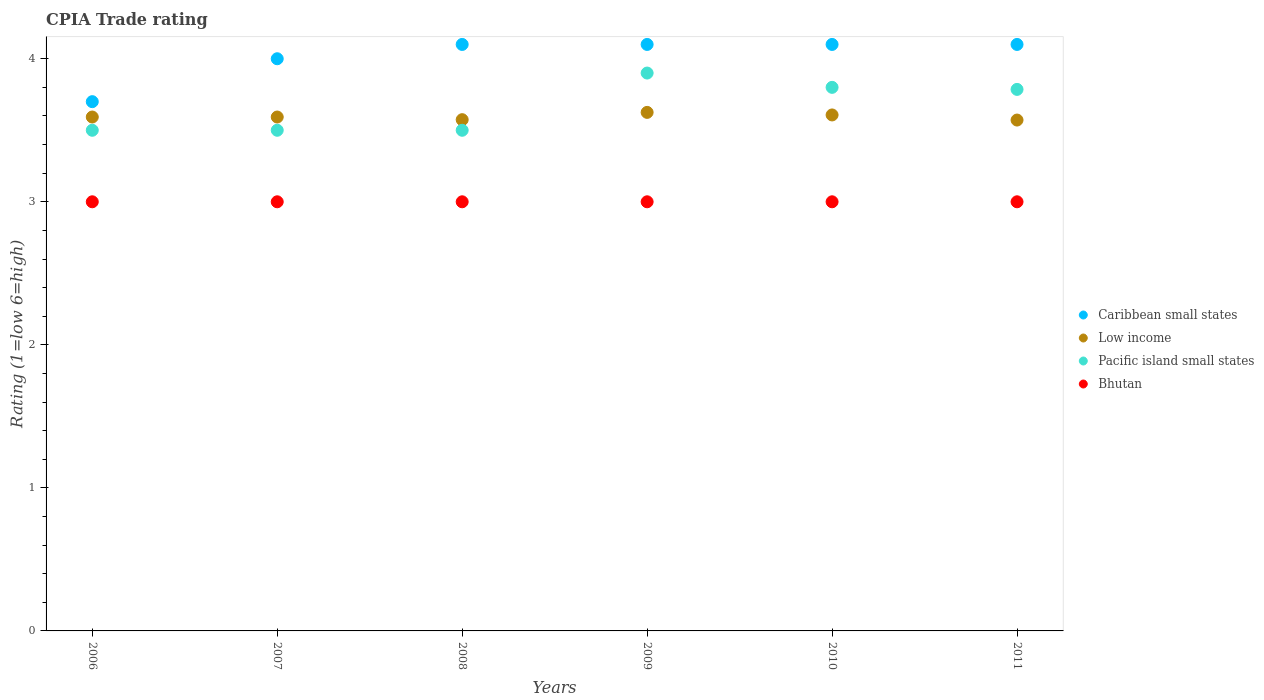How many different coloured dotlines are there?
Provide a short and direct response. 4. Is the number of dotlines equal to the number of legend labels?
Your response must be concise. Yes. What is the CPIA rating in Low income in 2009?
Give a very brief answer. 3.62. Across all years, what is the maximum CPIA rating in Bhutan?
Offer a very short reply. 3. In which year was the CPIA rating in Caribbean small states maximum?
Make the answer very short. 2008. In which year was the CPIA rating in Pacific island small states minimum?
Provide a short and direct response. 2006. What is the total CPIA rating in Low income in the graph?
Ensure brevity in your answer.  21.56. What is the difference between the CPIA rating in Bhutan in 2011 and the CPIA rating in Caribbean small states in 2010?
Provide a succinct answer. -1.1. What is the average CPIA rating in Caribbean small states per year?
Provide a succinct answer. 4.02. In the year 2010, what is the difference between the CPIA rating in Low income and CPIA rating in Bhutan?
Offer a terse response. 0.61. What is the ratio of the CPIA rating in Caribbean small states in 2007 to that in 2011?
Your answer should be compact. 0.98. What is the difference between the highest and the second highest CPIA rating in Low income?
Your answer should be very brief. 0.02. What is the difference between the highest and the lowest CPIA rating in Pacific island small states?
Your response must be concise. 0.4. In how many years, is the CPIA rating in Bhutan greater than the average CPIA rating in Bhutan taken over all years?
Your response must be concise. 0. Is the sum of the CPIA rating in Bhutan in 2007 and 2009 greater than the maximum CPIA rating in Caribbean small states across all years?
Keep it short and to the point. Yes. Is it the case that in every year, the sum of the CPIA rating in Pacific island small states and CPIA rating in Bhutan  is greater than the sum of CPIA rating in Low income and CPIA rating in Caribbean small states?
Offer a very short reply. Yes. Is the CPIA rating in Low income strictly less than the CPIA rating in Bhutan over the years?
Your response must be concise. No. How many dotlines are there?
Your response must be concise. 4. How many years are there in the graph?
Your answer should be very brief. 6. What is the difference between two consecutive major ticks on the Y-axis?
Offer a terse response. 1. Does the graph contain grids?
Provide a short and direct response. No. How many legend labels are there?
Your answer should be compact. 4. What is the title of the graph?
Your answer should be very brief. CPIA Trade rating. Does "Korea (Democratic)" appear as one of the legend labels in the graph?
Offer a very short reply. No. What is the label or title of the X-axis?
Your answer should be compact. Years. What is the label or title of the Y-axis?
Provide a succinct answer. Rating (1=low 6=high). What is the Rating (1=low 6=high) of Low income in 2006?
Keep it short and to the point. 3.59. What is the Rating (1=low 6=high) of Low income in 2007?
Offer a very short reply. 3.59. What is the Rating (1=low 6=high) in Pacific island small states in 2007?
Your response must be concise. 3.5. What is the Rating (1=low 6=high) of Low income in 2008?
Provide a short and direct response. 3.57. What is the Rating (1=low 6=high) in Caribbean small states in 2009?
Provide a succinct answer. 4.1. What is the Rating (1=low 6=high) of Low income in 2009?
Your answer should be compact. 3.62. What is the Rating (1=low 6=high) in Bhutan in 2009?
Keep it short and to the point. 3. What is the Rating (1=low 6=high) in Caribbean small states in 2010?
Keep it short and to the point. 4.1. What is the Rating (1=low 6=high) in Low income in 2010?
Offer a terse response. 3.61. What is the Rating (1=low 6=high) in Pacific island small states in 2010?
Give a very brief answer. 3.8. What is the Rating (1=low 6=high) in Bhutan in 2010?
Give a very brief answer. 3. What is the Rating (1=low 6=high) of Low income in 2011?
Ensure brevity in your answer.  3.57. What is the Rating (1=low 6=high) of Pacific island small states in 2011?
Your answer should be compact. 3.79. What is the Rating (1=low 6=high) of Bhutan in 2011?
Ensure brevity in your answer.  3. Across all years, what is the maximum Rating (1=low 6=high) of Caribbean small states?
Provide a short and direct response. 4.1. Across all years, what is the maximum Rating (1=low 6=high) of Low income?
Give a very brief answer. 3.62. Across all years, what is the maximum Rating (1=low 6=high) of Pacific island small states?
Your answer should be very brief. 3.9. Across all years, what is the minimum Rating (1=low 6=high) of Caribbean small states?
Give a very brief answer. 3.7. Across all years, what is the minimum Rating (1=low 6=high) of Low income?
Make the answer very short. 3.57. What is the total Rating (1=low 6=high) of Caribbean small states in the graph?
Provide a short and direct response. 24.1. What is the total Rating (1=low 6=high) in Low income in the graph?
Give a very brief answer. 21.56. What is the total Rating (1=low 6=high) in Pacific island small states in the graph?
Provide a succinct answer. 21.99. What is the difference between the Rating (1=low 6=high) of Low income in 2006 and that in 2007?
Ensure brevity in your answer.  0. What is the difference between the Rating (1=low 6=high) of Low income in 2006 and that in 2008?
Keep it short and to the point. 0.02. What is the difference between the Rating (1=low 6=high) in Pacific island small states in 2006 and that in 2008?
Provide a succinct answer. 0. What is the difference between the Rating (1=low 6=high) of Bhutan in 2006 and that in 2008?
Offer a very short reply. 0. What is the difference between the Rating (1=low 6=high) of Low income in 2006 and that in 2009?
Ensure brevity in your answer.  -0.03. What is the difference between the Rating (1=low 6=high) in Pacific island small states in 2006 and that in 2009?
Ensure brevity in your answer.  -0.4. What is the difference between the Rating (1=low 6=high) in Caribbean small states in 2006 and that in 2010?
Provide a succinct answer. -0.4. What is the difference between the Rating (1=low 6=high) of Low income in 2006 and that in 2010?
Give a very brief answer. -0.01. What is the difference between the Rating (1=low 6=high) of Pacific island small states in 2006 and that in 2010?
Your answer should be very brief. -0.3. What is the difference between the Rating (1=low 6=high) in Bhutan in 2006 and that in 2010?
Ensure brevity in your answer.  0. What is the difference between the Rating (1=low 6=high) of Low income in 2006 and that in 2011?
Offer a terse response. 0.02. What is the difference between the Rating (1=low 6=high) of Pacific island small states in 2006 and that in 2011?
Provide a succinct answer. -0.29. What is the difference between the Rating (1=low 6=high) in Bhutan in 2006 and that in 2011?
Offer a very short reply. 0. What is the difference between the Rating (1=low 6=high) of Low income in 2007 and that in 2008?
Keep it short and to the point. 0.02. What is the difference between the Rating (1=low 6=high) in Caribbean small states in 2007 and that in 2009?
Your response must be concise. -0.1. What is the difference between the Rating (1=low 6=high) of Low income in 2007 and that in 2009?
Your response must be concise. -0.03. What is the difference between the Rating (1=low 6=high) in Pacific island small states in 2007 and that in 2009?
Your answer should be compact. -0.4. What is the difference between the Rating (1=low 6=high) of Low income in 2007 and that in 2010?
Offer a very short reply. -0.01. What is the difference between the Rating (1=low 6=high) of Bhutan in 2007 and that in 2010?
Provide a short and direct response. 0. What is the difference between the Rating (1=low 6=high) in Low income in 2007 and that in 2011?
Your answer should be compact. 0.02. What is the difference between the Rating (1=low 6=high) in Pacific island small states in 2007 and that in 2011?
Offer a terse response. -0.29. What is the difference between the Rating (1=low 6=high) of Bhutan in 2007 and that in 2011?
Give a very brief answer. 0. What is the difference between the Rating (1=low 6=high) of Low income in 2008 and that in 2009?
Provide a short and direct response. -0.05. What is the difference between the Rating (1=low 6=high) of Pacific island small states in 2008 and that in 2009?
Provide a short and direct response. -0.4. What is the difference between the Rating (1=low 6=high) of Bhutan in 2008 and that in 2009?
Give a very brief answer. 0. What is the difference between the Rating (1=low 6=high) of Caribbean small states in 2008 and that in 2010?
Keep it short and to the point. 0. What is the difference between the Rating (1=low 6=high) in Low income in 2008 and that in 2010?
Give a very brief answer. -0.03. What is the difference between the Rating (1=low 6=high) in Pacific island small states in 2008 and that in 2010?
Your answer should be very brief. -0.3. What is the difference between the Rating (1=low 6=high) of Bhutan in 2008 and that in 2010?
Provide a succinct answer. 0. What is the difference between the Rating (1=low 6=high) of Low income in 2008 and that in 2011?
Your answer should be compact. 0. What is the difference between the Rating (1=low 6=high) of Pacific island small states in 2008 and that in 2011?
Provide a succinct answer. -0.29. What is the difference between the Rating (1=low 6=high) in Bhutan in 2008 and that in 2011?
Ensure brevity in your answer.  0. What is the difference between the Rating (1=low 6=high) in Low income in 2009 and that in 2010?
Ensure brevity in your answer.  0.02. What is the difference between the Rating (1=low 6=high) of Bhutan in 2009 and that in 2010?
Offer a very short reply. 0. What is the difference between the Rating (1=low 6=high) of Low income in 2009 and that in 2011?
Give a very brief answer. 0.05. What is the difference between the Rating (1=low 6=high) in Pacific island small states in 2009 and that in 2011?
Your response must be concise. 0.11. What is the difference between the Rating (1=low 6=high) of Bhutan in 2009 and that in 2011?
Make the answer very short. 0. What is the difference between the Rating (1=low 6=high) in Low income in 2010 and that in 2011?
Provide a short and direct response. 0.04. What is the difference between the Rating (1=low 6=high) in Pacific island small states in 2010 and that in 2011?
Provide a short and direct response. 0.01. What is the difference between the Rating (1=low 6=high) in Caribbean small states in 2006 and the Rating (1=low 6=high) in Low income in 2007?
Make the answer very short. 0.11. What is the difference between the Rating (1=low 6=high) in Caribbean small states in 2006 and the Rating (1=low 6=high) in Pacific island small states in 2007?
Give a very brief answer. 0.2. What is the difference between the Rating (1=low 6=high) in Caribbean small states in 2006 and the Rating (1=low 6=high) in Bhutan in 2007?
Provide a short and direct response. 0.7. What is the difference between the Rating (1=low 6=high) of Low income in 2006 and the Rating (1=low 6=high) of Pacific island small states in 2007?
Ensure brevity in your answer.  0.09. What is the difference between the Rating (1=low 6=high) in Low income in 2006 and the Rating (1=low 6=high) in Bhutan in 2007?
Make the answer very short. 0.59. What is the difference between the Rating (1=low 6=high) in Pacific island small states in 2006 and the Rating (1=low 6=high) in Bhutan in 2007?
Your response must be concise. 0.5. What is the difference between the Rating (1=low 6=high) in Caribbean small states in 2006 and the Rating (1=low 6=high) in Low income in 2008?
Give a very brief answer. 0.13. What is the difference between the Rating (1=low 6=high) of Low income in 2006 and the Rating (1=low 6=high) of Pacific island small states in 2008?
Keep it short and to the point. 0.09. What is the difference between the Rating (1=low 6=high) in Low income in 2006 and the Rating (1=low 6=high) in Bhutan in 2008?
Provide a succinct answer. 0.59. What is the difference between the Rating (1=low 6=high) of Caribbean small states in 2006 and the Rating (1=low 6=high) of Low income in 2009?
Give a very brief answer. 0.07. What is the difference between the Rating (1=low 6=high) of Caribbean small states in 2006 and the Rating (1=low 6=high) of Pacific island small states in 2009?
Offer a very short reply. -0.2. What is the difference between the Rating (1=low 6=high) of Caribbean small states in 2006 and the Rating (1=low 6=high) of Bhutan in 2009?
Keep it short and to the point. 0.7. What is the difference between the Rating (1=low 6=high) of Low income in 2006 and the Rating (1=low 6=high) of Pacific island small states in 2009?
Give a very brief answer. -0.31. What is the difference between the Rating (1=low 6=high) in Low income in 2006 and the Rating (1=low 6=high) in Bhutan in 2009?
Your answer should be compact. 0.59. What is the difference between the Rating (1=low 6=high) in Caribbean small states in 2006 and the Rating (1=low 6=high) in Low income in 2010?
Make the answer very short. 0.09. What is the difference between the Rating (1=low 6=high) of Caribbean small states in 2006 and the Rating (1=low 6=high) of Pacific island small states in 2010?
Your answer should be compact. -0.1. What is the difference between the Rating (1=low 6=high) of Caribbean small states in 2006 and the Rating (1=low 6=high) of Bhutan in 2010?
Your answer should be compact. 0.7. What is the difference between the Rating (1=low 6=high) in Low income in 2006 and the Rating (1=low 6=high) in Pacific island small states in 2010?
Ensure brevity in your answer.  -0.21. What is the difference between the Rating (1=low 6=high) in Low income in 2006 and the Rating (1=low 6=high) in Bhutan in 2010?
Make the answer very short. 0.59. What is the difference between the Rating (1=low 6=high) in Caribbean small states in 2006 and the Rating (1=low 6=high) in Low income in 2011?
Offer a terse response. 0.13. What is the difference between the Rating (1=low 6=high) of Caribbean small states in 2006 and the Rating (1=low 6=high) of Pacific island small states in 2011?
Give a very brief answer. -0.09. What is the difference between the Rating (1=low 6=high) in Low income in 2006 and the Rating (1=low 6=high) in Pacific island small states in 2011?
Your response must be concise. -0.19. What is the difference between the Rating (1=low 6=high) of Low income in 2006 and the Rating (1=low 6=high) of Bhutan in 2011?
Make the answer very short. 0.59. What is the difference between the Rating (1=low 6=high) of Caribbean small states in 2007 and the Rating (1=low 6=high) of Low income in 2008?
Offer a very short reply. 0.43. What is the difference between the Rating (1=low 6=high) in Caribbean small states in 2007 and the Rating (1=low 6=high) in Pacific island small states in 2008?
Make the answer very short. 0.5. What is the difference between the Rating (1=low 6=high) in Caribbean small states in 2007 and the Rating (1=low 6=high) in Bhutan in 2008?
Give a very brief answer. 1. What is the difference between the Rating (1=low 6=high) in Low income in 2007 and the Rating (1=low 6=high) in Pacific island small states in 2008?
Offer a very short reply. 0.09. What is the difference between the Rating (1=low 6=high) of Low income in 2007 and the Rating (1=low 6=high) of Bhutan in 2008?
Provide a short and direct response. 0.59. What is the difference between the Rating (1=low 6=high) in Caribbean small states in 2007 and the Rating (1=low 6=high) in Low income in 2009?
Make the answer very short. 0.38. What is the difference between the Rating (1=low 6=high) of Caribbean small states in 2007 and the Rating (1=low 6=high) of Bhutan in 2009?
Offer a terse response. 1. What is the difference between the Rating (1=low 6=high) in Low income in 2007 and the Rating (1=low 6=high) in Pacific island small states in 2009?
Keep it short and to the point. -0.31. What is the difference between the Rating (1=low 6=high) in Low income in 2007 and the Rating (1=low 6=high) in Bhutan in 2009?
Make the answer very short. 0.59. What is the difference between the Rating (1=low 6=high) of Pacific island small states in 2007 and the Rating (1=low 6=high) of Bhutan in 2009?
Offer a very short reply. 0.5. What is the difference between the Rating (1=low 6=high) in Caribbean small states in 2007 and the Rating (1=low 6=high) in Low income in 2010?
Keep it short and to the point. 0.39. What is the difference between the Rating (1=low 6=high) in Caribbean small states in 2007 and the Rating (1=low 6=high) in Pacific island small states in 2010?
Offer a terse response. 0.2. What is the difference between the Rating (1=low 6=high) in Low income in 2007 and the Rating (1=low 6=high) in Pacific island small states in 2010?
Offer a very short reply. -0.21. What is the difference between the Rating (1=low 6=high) of Low income in 2007 and the Rating (1=low 6=high) of Bhutan in 2010?
Make the answer very short. 0.59. What is the difference between the Rating (1=low 6=high) of Caribbean small states in 2007 and the Rating (1=low 6=high) of Low income in 2011?
Offer a terse response. 0.43. What is the difference between the Rating (1=low 6=high) in Caribbean small states in 2007 and the Rating (1=low 6=high) in Pacific island small states in 2011?
Your response must be concise. 0.21. What is the difference between the Rating (1=low 6=high) of Caribbean small states in 2007 and the Rating (1=low 6=high) of Bhutan in 2011?
Offer a very short reply. 1. What is the difference between the Rating (1=low 6=high) of Low income in 2007 and the Rating (1=low 6=high) of Pacific island small states in 2011?
Your answer should be very brief. -0.19. What is the difference between the Rating (1=low 6=high) of Low income in 2007 and the Rating (1=low 6=high) of Bhutan in 2011?
Give a very brief answer. 0.59. What is the difference between the Rating (1=low 6=high) of Pacific island small states in 2007 and the Rating (1=low 6=high) of Bhutan in 2011?
Your answer should be very brief. 0.5. What is the difference between the Rating (1=low 6=high) of Caribbean small states in 2008 and the Rating (1=low 6=high) of Low income in 2009?
Ensure brevity in your answer.  0.47. What is the difference between the Rating (1=low 6=high) of Caribbean small states in 2008 and the Rating (1=low 6=high) of Bhutan in 2009?
Ensure brevity in your answer.  1.1. What is the difference between the Rating (1=low 6=high) of Low income in 2008 and the Rating (1=low 6=high) of Pacific island small states in 2009?
Offer a terse response. -0.33. What is the difference between the Rating (1=low 6=high) of Low income in 2008 and the Rating (1=low 6=high) of Bhutan in 2009?
Make the answer very short. 0.57. What is the difference between the Rating (1=low 6=high) in Pacific island small states in 2008 and the Rating (1=low 6=high) in Bhutan in 2009?
Provide a short and direct response. 0.5. What is the difference between the Rating (1=low 6=high) in Caribbean small states in 2008 and the Rating (1=low 6=high) in Low income in 2010?
Keep it short and to the point. 0.49. What is the difference between the Rating (1=low 6=high) in Caribbean small states in 2008 and the Rating (1=low 6=high) in Pacific island small states in 2010?
Give a very brief answer. 0.3. What is the difference between the Rating (1=low 6=high) of Caribbean small states in 2008 and the Rating (1=low 6=high) of Bhutan in 2010?
Your response must be concise. 1.1. What is the difference between the Rating (1=low 6=high) in Low income in 2008 and the Rating (1=low 6=high) in Pacific island small states in 2010?
Make the answer very short. -0.23. What is the difference between the Rating (1=low 6=high) in Low income in 2008 and the Rating (1=low 6=high) in Bhutan in 2010?
Give a very brief answer. 0.57. What is the difference between the Rating (1=low 6=high) in Pacific island small states in 2008 and the Rating (1=low 6=high) in Bhutan in 2010?
Provide a short and direct response. 0.5. What is the difference between the Rating (1=low 6=high) in Caribbean small states in 2008 and the Rating (1=low 6=high) in Low income in 2011?
Your answer should be compact. 0.53. What is the difference between the Rating (1=low 6=high) in Caribbean small states in 2008 and the Rating (1=low 6=high) in Pacific island small states in 2011?
Ensure brevity in your answer.  0.31. What is the difference between the Rating (1=low 6=high) in Low income in 2008 and the Rating (1=low 6=high) in Pacific island small states in 2011?
Offer a very short reply. -0.21. What is the difference between the Rating (1=low 6=high) of Low income in 2008 and the Rating (1=low 6=high) of Bhutan in 2011?
Your response must be concise. 0.57. What is the difference between the Rating (1=low 6=high) in Pacific island small states in 2008 and the Rating (1=low 6=high) in Bhutan in 2011?
Your answer should be very brief. 0.5. What is the difference between the Rating (1=low 6=high) of Caribbean small states in 2009 and the Rating (1=low 6=high) of Low income in 2010?
Provide a short and direct response. 0.49. What is the difference between the Rating (1=low 6=high) in Low income in 2009 and the Rating (1=low 6=high) in Pacific island small states in 2010?
Provide a succinct answer. -0.17. What is the difference between the Rating (1=low 6=high) of Low income in 2009 and the Rating (1=low 6=high) of Bhutan in 2010?
Give a very brief answer. 0.62. What is the difference between the Rating (1=low 6=high) in Pacific island small states in 2009 and the Rating (1=low 6=high) in Bhutan in 2010?
Your response must be concise. 0.9. What is the difference between the Rating (1=low 6=high) in Caribbean small states in 2009 and the Rating (1=low 6=high) in Low income in 2011?
Offer a very short reply. 0.53. What is the difference between the Rating (1=low 6=high) of Caribbean small states in 2009 and the Rating (1=low 6=high) of Pacific island small states in 2011?
Give a very brief answer. 0.31. What is the difference between the Rating (1=low 6=high) of Caribbean small states in 2009 and the Rating (1=low 6=high) of Bhutan in 2011?
Provide a short and direct response. 1.1. What is the difference between the Rating (1=low 6=high) of Low income in 2009 and the Rating (1=low 6=high) of Pacific island small states in 2011?
Keep it short and to the point. -0.16. What is the difference between the Rating (1=low 6=high) in Pacific island small states in 2009 and the Rating (1=low 6=high) in Bhutan in 2011?
Keep it short and to the point. 0.9. What is the difference between the Rating (1=low 6=high) in Caribbean small states in 2010 and the Rating (1=low 6=high) in Low income in 2011?
Your response must be concise. 0.53. What is the difference between the Rating (1=low 6=high) in Caribbean small states in 2010 and the Rating (1=low 6=high) in Pacific island small states in 2011?
Give a very brief answer. 0.31. What is the difference between the Rating (1=low 6=high) of Low income in 2010 and the Rating (1=low 6=high) of Pacific island small states in 2011?
Your answer should be very brief. -0.18. What is the difference between the Rating (1=low 6=high) of Low income in 2010 and the Rating (1=low 6=high) of Bhutan in 2011?
Your answer should be compact. 0.61. What is the average Rating (1=low 6=high) in Caribbean small states per year?
Ensure brevity in your answer.  4.02. What is the average Rating (1=low 6=high) in Low income per year?
Give a very brief answer. 3.59. What is the average Rating (1=low 6=high) in Pacific island small states per year?
Your answer should be very brief. 3.66. In the year 2006, what is the difference between the Rating (1=low 6=high) of Caribbean small states and Rating (1=low 6=high) of Low income?
Ensure brevity in your answer.  0.11. In the year 2006, what is the difference between the Rating (1=low 6=high) in Caribbean small states and Rating (1=low 6=high) in Pacific island small states?
Give a very brief answer. 0.2. In the year 2006, what is the difference between the Rating (1=low 6=high) in Low income and Rating (1=low 6=high) in Pacific island small states?
Offer a terse response. 0.09. In the year 2006, what is the difference between the Rating (1=low 6=high) in Low income and Rating (1=low 6=high) in Bhutan?
Provide a short and direct response. 0.59. In the year 2007, what is the difference between the Rating (1=low 6=high) of Caribbean small states and Rating (1=low 6=high) of Low income?
Your answer should be compact. 0.41. In the year 2007, what is the difference between the Rating (1=low 6=high) of Caribbean small states and Rating (1=low 6=high) of Pacific island small states?
Offer a very short reply. 0.5. In the year 2007, what is the difference between the Rating (1=low 6=high) of Low income and Rating (1=low 6=high) of Pacific island small states?
Your answer should be compact. 0.09. In the year 2007, what is the difference between the Rating (1=low 6=high) in Low income and Rating (1=low 6=high) in Bhutan?
Your answer should be very brief. 0.59. In the year 2007, what is the difference between the Rating (1=low 6=high) of Pacific island small states and Rating (1=low 6=high) of Bhutan?
Your answer should be very brief. 0.5. In the year 2008, what is the difference between the Rating (1=low 6=high) of Caribbean small states and Rating (1=low 6=high) of Low income?
Offer a very short reply. 0.53. In the year 2008, what is the difference between the Rating (1=low 6=high) in Low income and Rating (1=low 6=high) in Pacific island small states?
Your response must be concise. 0.07. In the year 2008, what is the difference between the Rating (1=low 6=high) in Low income and Rating (1=low 6=high) in Bhutan?
Provide a short and direct response. 0.57. In the year 2009, what is the difference between the Rating (1=low 6=high) of Caribbean small states and Rating (1=low 6=high) of Low income?
Offer a terse response. 0.47. In the year 2009, what is the difference between the Rating (1=low 6=high) in Caribbean small states and Rating (1=low 6=high) in Bhutan?
Offer a terse response. 1.1. In the year 2009, what is the difference between the Rating (1=low 6=high) in Low income and Rating (1=low 6=high) in Pacific island small states?
Provide a succinct answer. -0.28. In the year 2009, what is the difference between the Rating (1=low 6=high) of Low income and Rating (1=low 6=high) of Bhutan?
Your answer should be compact. 0.62. In the year 2010, what is the difference between the Rating (1=low 6=high) in Caribbean small states and Rating (1=low 6=high) in Low income?
Ensure brevity in your answer.  0.49. In the year 2010, what is the difference between the Rating (1=low 6=high) in Caribbean small states and Rating (1=low 6=high) in Bhutan?
Provide a succinct answer. 1.1. In the year 2010, what is the difference between the Rating (1=low 6=high) in Low income and Rating (1=low 6=high) in Pacific island small states?
Give a very brief answer. -0.19. In the year 2010, what is the difference between the Rating (1=low 6=high) in Low income and Rating (1=low 6=high) in Bhutan?
Your response must be concise. 0.61. In the year 2010, what is the difference between the Rating (1=low 6=high) of Pacific island small states and Rating (1=low 6=high) of Bhutan?
Give a very brief answer. 0.8. In the year 2011, what is the difference between the Rating (1=low 6=high) of Caribbean small states and Rating (1=low 6=high) of Low income?
Offer a terse response. 0.53. In the year 2011, what is the difference between the Rating (1=low 6=high) in Caribbean small states and Rating (1=low 6=high) in Pacific island small states?
Provide a short and direct response. 0.31. In the year 2011, what is the difference between the Rating (1=low 6=high) in Low income and Rating (1=low 6=high) in Pacific island small states?
Give a very brief answer. -0.21. In the year 2011, what is the difference between the Rating (1=low 6=high) of Low income and Rating (1=low 6=high) of Bhutan?
Provide a succinct answer. 0.57. In the year 2011, what is the difference between the Rating (1=low 6=high) in Pacific island small states and Rating (1=low 6=high) in Bhutan?
Provide a succinct answer. 0.79. What is the ratio of the Rating (1=low 6=high) of Caribbean small states in 2006 to that in 2007?
Your response must be concise. 0.93. What is the ratio of the Rating (1=low 6=high) of Low income in 2006 to that in 2007?
Provide a short and direct response. 1. What is the ratio of the Rating (1=low 6=high) of Pacific island small states in 2006 to that in 2007?
Your response must be concise. 1. What is the ratio of the Rating (1=low 6=high) in Bhutan in 2006 to that in 2007?
Your answer should be very brief. 1. What is the ratio of the Rating (1=low 6=high) of Caribbean small states in 2006 to that in 2008?
Give a very brief answer. 0.9. What is the ratio of the Rating (1=low 6=high) in Low income in 2006 to that in 2008?
Keep it short and to the point. 1.01. What is the ratio of the Rating (1=low 6=high) of Pacific island small states in 2006 to that in 2008?
Ensure brevity in your answer.  1. What is the ratio of the Rating (1=low 6=high) of Bhutan in 2006 to that in 2008?
Make the answer very short. 1. What is the ratio of the Rating (1=low 6=high) of Caribbean small states in 2006 to that in 2009?
Offer a very short reply. 0.9. What is the ratio of the Rating (1=low 6=high) in Pacific island small states in 2006 to that in 2009?
Keep it short and to the point. 0.9. What is the ratio of the Rating (1=low 6=high) of Caribbean small states in 2006 to that in 2010?
Provide a short and direct response. 0.9. What is the ratio of the Rating (1=low 6=high) of Pacific island small states in 2006 to that in 2010?
Your response must be concise. 0.92. What is the ratio of the Rating (1=low 6=high) in Bhutan in 2006 to that in 2010?
Keep it short and to the point. 1. What is the ratio of the Rating (1=low 6=high) in Caribbean small states in 2006 to that in 2011?
Provide a short and direct response. 0.9. What is the ratio of the Rating (1=low 6=high) of Low income in 2006 to that in 2011?
Provide a succinct answer. 1.01. What is the ratio of the Rating (1=low 6=high) of Pacific island small states in 2006 to that in 2011?
Provide a succinct answer. 0.92. What is the ratio of the Rating (1=low 6=high) in Bhutan in 2006 to that in 2011?
Your answer should be compact. 1. What is the ratio of the Rating (1=low 6=high) of Caribbean small states in 2007 to that in 2008?
Make the answer very short. 0.98. What is the ratio of the Rating (1=low 6=high) in Caribbean small states in 2007 to that in 2009?
Give a very brief answer. 0.98. What is the ratio of the Rating (1=low 6=high) of Low income in 2007 to that in 2009?
Offer a terse response. 0.99. What is the ratio of the Rating (1=low 6=high) of Pacific island small states in 2007 to that in 2009?
Provide a succinct answer. 0.9. What is the ratio of the Rating (1=low 6=high) of Bhutan in 2007 to that in 2009?
Your answer should be very brief. 1. What is the ratio of the Rating (1=low 6=high) of Caribbean small states in 2007 to that in 2010?
Your answer should be very brief. 0.98. What is the ratio of the Rating (1=low 6=high) of Low income in 2007 to that in 2010?
Offer a very short reply. 1. What is the ratio of the Rating (1=low 6=high) in Pacific island small states in 2007 to that in 2010?
Provide a succinct answer. 0.92. What is the ratio of the Rating (1=low 6=high) in Bhutan in 2007 to that in 2010?
Your response must be concise. 1. What is the ratio of the Rating (1=low 6=high) of Caribbean small states in 2007 to that in 2011?
Your answer should be compact. 0.98. What is the ratio of the Rating (1=low 6=high) of Low income in 2007 to that in 2011?
Provide a succinct answer. 1.01. What is the ratio of the Rating (1=low 6=high) of Pacific island small states in 2007 to that in 2011?
Provide a short and direct response. 0.92. What is the ratio of the Rating (1=low 6=high) in Pacific island small states in 2008 to that in 2009?
Your response must be concise. 0.9. What is the ratio of the Rating (1=low 6=high) in Bhutan in 2008 to that in 2009?
Your response must be concise. 1. What is the ratio of the Rating (1=low 6=high) in Low income in 2008 to that in 2010?
Provide a succinct answer. 0.99. What is the ratio of the Rating (1=low 6=high) in Pacific island small states in 2008 to that in 2010?
Your response must be concise. 0.92. What is the ratio of the Rating (1=low 6=high) of Bhutan in 2008 to that in 2010?
Offer a terse response. 1. What is the ratio of the Rating (1=low 6=high) in Pacific island small states in 2008 to that in 2011?
Give a very brief answer. 0.92. What is the ratio of the Rating (1=low 6=high) in Caribbean small states in 2009 to that in 2010?
Provide a succinct answer. 1. What is the ratio of the Rating (1=low 6=high) in Low income in 2009 to that in 2010?
Your response must be concise. 1. What is the ratio of the Rating (1=low 6=high) in Pacific island small states in 2009 to that in 2010?
Your answer should be compact. 1.03. What is the ratio of the Rating (1=low 6=high) in Bhutan in 2009 to that in 2010?
Provide a succinct answer. 1. What is the ratio of the Rating (1=low 6=high) of Low income in 2009 to that in 2011?
Your answer should be compact. 1.01. What is the ratio of the Rating (1=low 6=high) in Pacific island small states in 2009 to that in 2011?
Give a very brief answer. 1.03. What is the ratio of the Rating (1=low 6=high) of Pacific island small states in 2010 to that in 2011?
Offer a terse response. 1. What is the ratio of the Rating (1=low 6=high) in Bhutan in 2010 to that in 2011?
Provide a short and direct response. 1. What is the difference between the highest and the second highest Rating (1=low 6=high) in Caribbean small states?
Keep it short and to the point. 0. What is the difference between the highest and the second highest Rating (1=low 6=high) in Low income?
Offer a very short reply. 0.02. What is the difference between the highest and the lowest Rating (1=low 6=high) of Caribbean small states?
Keep it short and to the point. 0.4. What is the difference between the highest and the lowest Rating (1=low 6=high) of Low income?
Give a very brief answer. 0.05. 